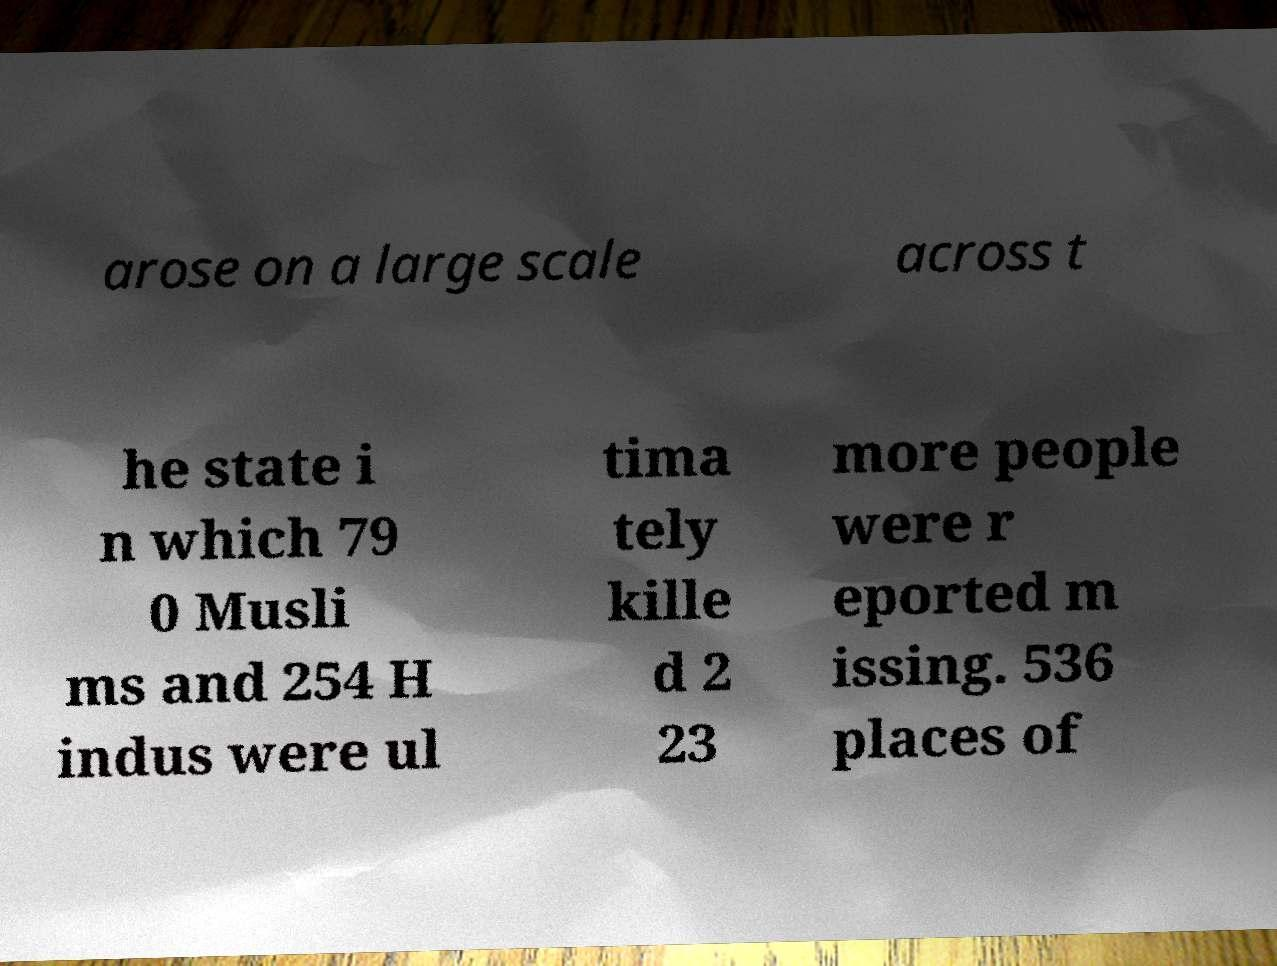Could you extract and type out the text from this image? arose on a large scale across t he state i n which 79 0 Musli ms and 254 H indus were ul tima tely kille d 2 23 more people were r eported m issing. 536 places of 